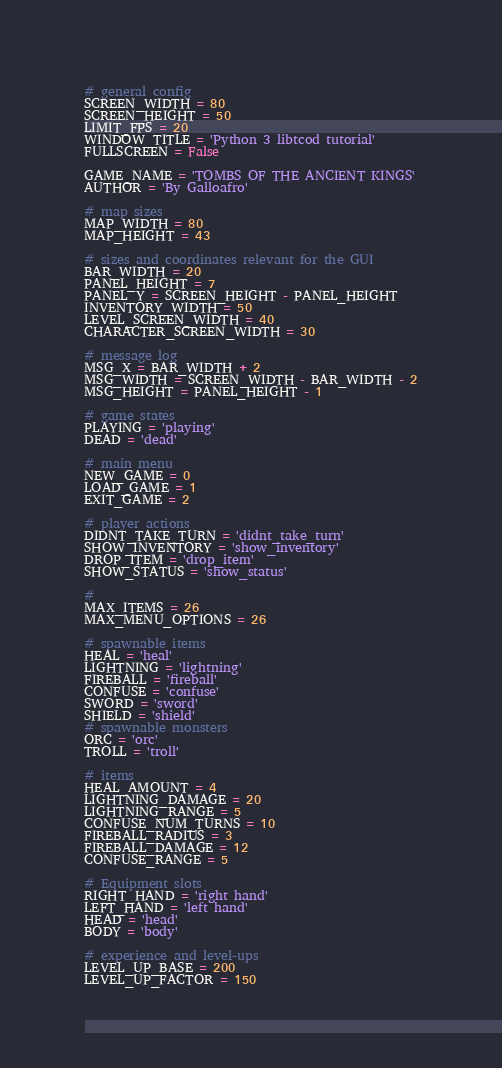<code> <loc_0><loc_0><loc_500><loc_500><_Python_># general config
SCREEN_WIDTH = 80
SCREEN_HEIGHT = 50
LIMIT_FPS = 20
WINDOW_TITLE = 'Python 3 libtcod tutorial'
FULLSCREEN = False

GAME_NAME = 'TOMBS OF THE ANCIENT KINGS'
AUTHOR = 'By Galloafro'

# map sizes
MAP_WIDTH = 80
MAP_HEIGHT = 43

# sizes and coordinates relevant for the GUI
BAR_WIDTH = 20
PANEL_HEIGHT = 7
PANEL_Y = SCREEN_HEIGHT - PANEL_HEIGHT
INVENTORY_WIDTH = 50
LEVEL_SCREEN_WIDTH = 40
CHARACTER_SCREEN_WIDTH = 30

# message log
MSG_X = BAR_WIDTH + 2
MSG_WIDTH = SCREEN_WIDTH - BAR_WIDTH - 2
MSG_HEIGHT = PANEL_HEIGHT - 1

# game states
PLAYING = 'playing'
DEAD = 'dead'

# main menu
NEW_GAME = 0
LOAD_GAME = 1
EXIT_GAME = 2

# player actions
DIDNT_TAKE_TURN = 'didnt_take_turn'
SHOW_INVENTORY = 'show_inventory'
DROP_ITEM = 'drop_item'
SHOW_STATUS = 'show_status'

# 
MAX_ITEMS = 26
MAX_MENU_OPTIONS = 26

# spawnable items
HEAL = 'heal'
LIGHTNING = 'lightning'
FIREBALL = 'fireball'
CONFUSE = 'confuse'
SWORD = 'sword'
SHIELD = 'shield'
# spawnable monsters
ORC = 'orc'
TROLL = 'troll'

# items
HEAL_AMOUNT = 4
LIGHTNING_DAMAGE = 20
LIGHTNING_RANGE = 5
CONFUSE_NUM_TURNS = 10
FIREBALL_RADIUS = 3
FIREBALL_DAMAGE = 12
CONFUSE_RANGE = 5

# Equipment slots
RIGHT_HAND = 'right hand'
LEFT_HAND = 'left hand'
HEAD = 'head'
BODY = 'body'

# experience and level-ups
LEVEL_UP_BASE = 200
LEVEL_UP_FACTOR = 150</code> 